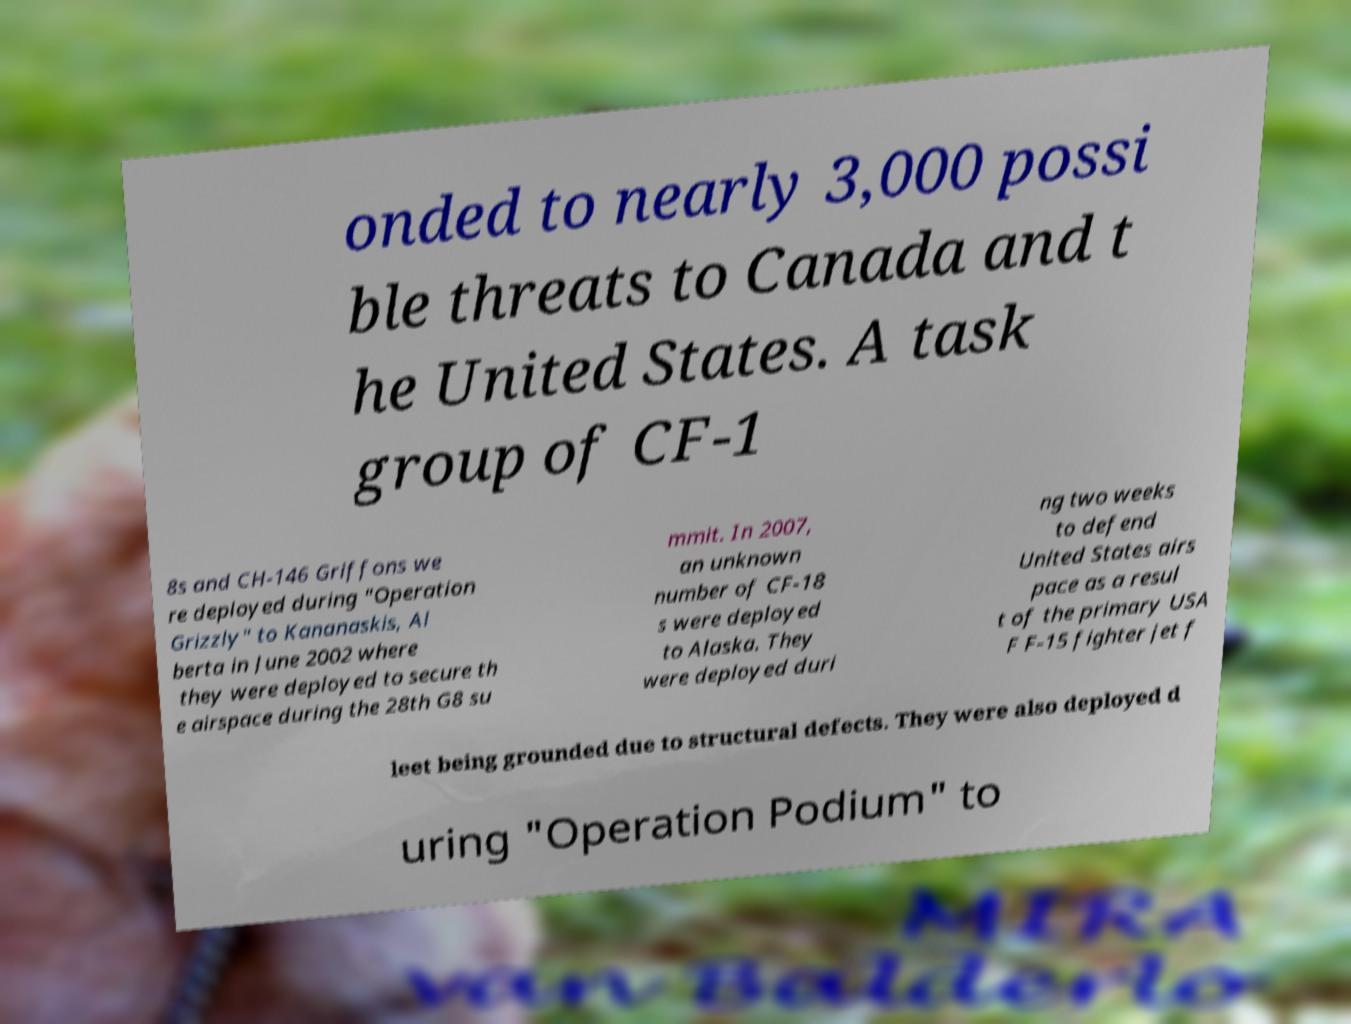I need the written content from this picture converted into text. Can you do that? onded to nearly 3,000 possi ble threats to Canada and t he United States. A task group of CF-1 8s and CH-146 Griffons we re deployed during "Operation Grizzly" to Kananaskis, Al berta in June 2002 where they were deployed to secure th e airspace during the 28th G8 su mmit. In 2007, an unknown number of CF-18 s were deployed to Alaska. They were deployed duri ng two weeks to defend United States airs pace as a resul t of the primary USA F F-15 fighter jet f leet being grounded due to structural defects. They were also deployed d uring "Operation Podium" to 